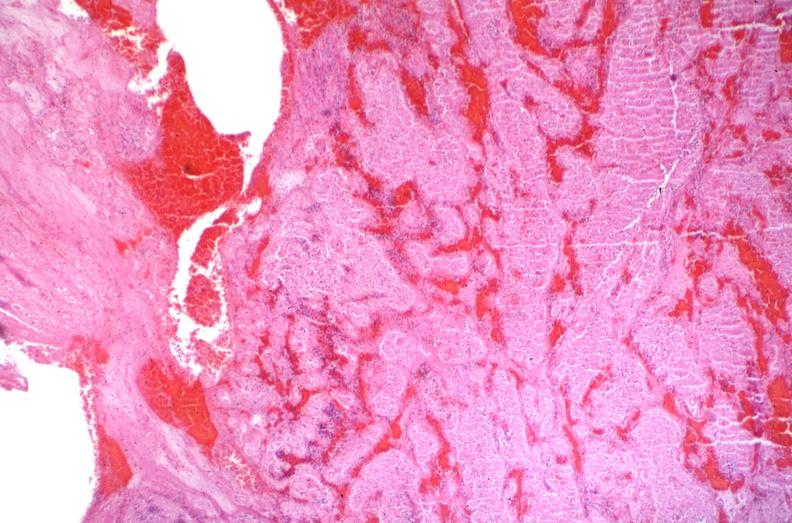where is this from?
Answer the question using a single word or phrase. Vasculature 